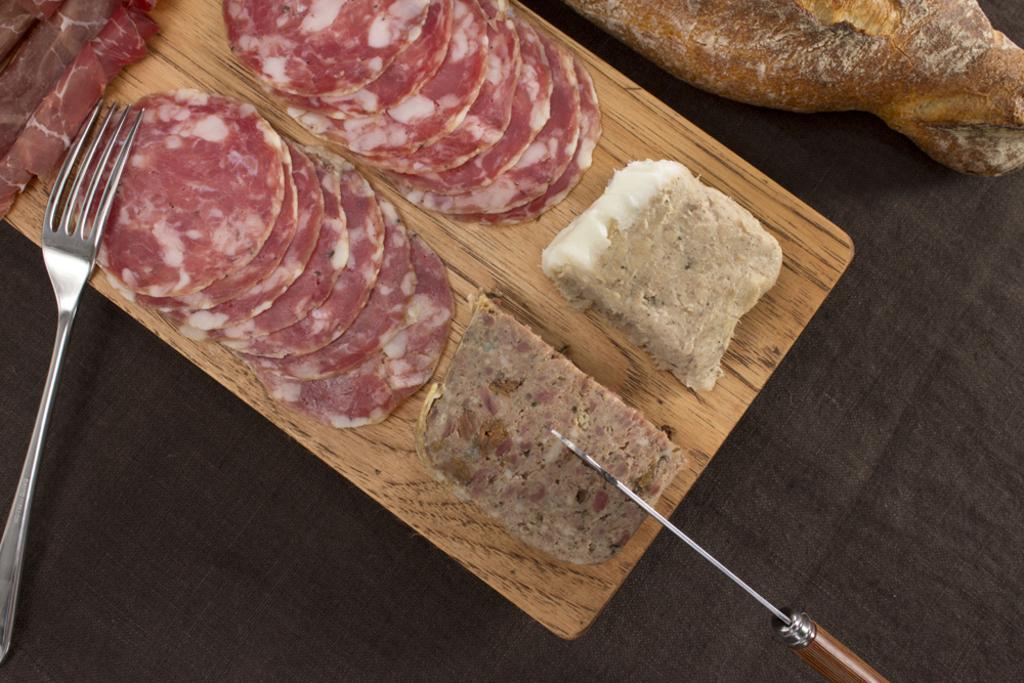In one or two sentences, can you explain what this image depicts? In this picture we can see a fork, knife and food on the wooden plank. 